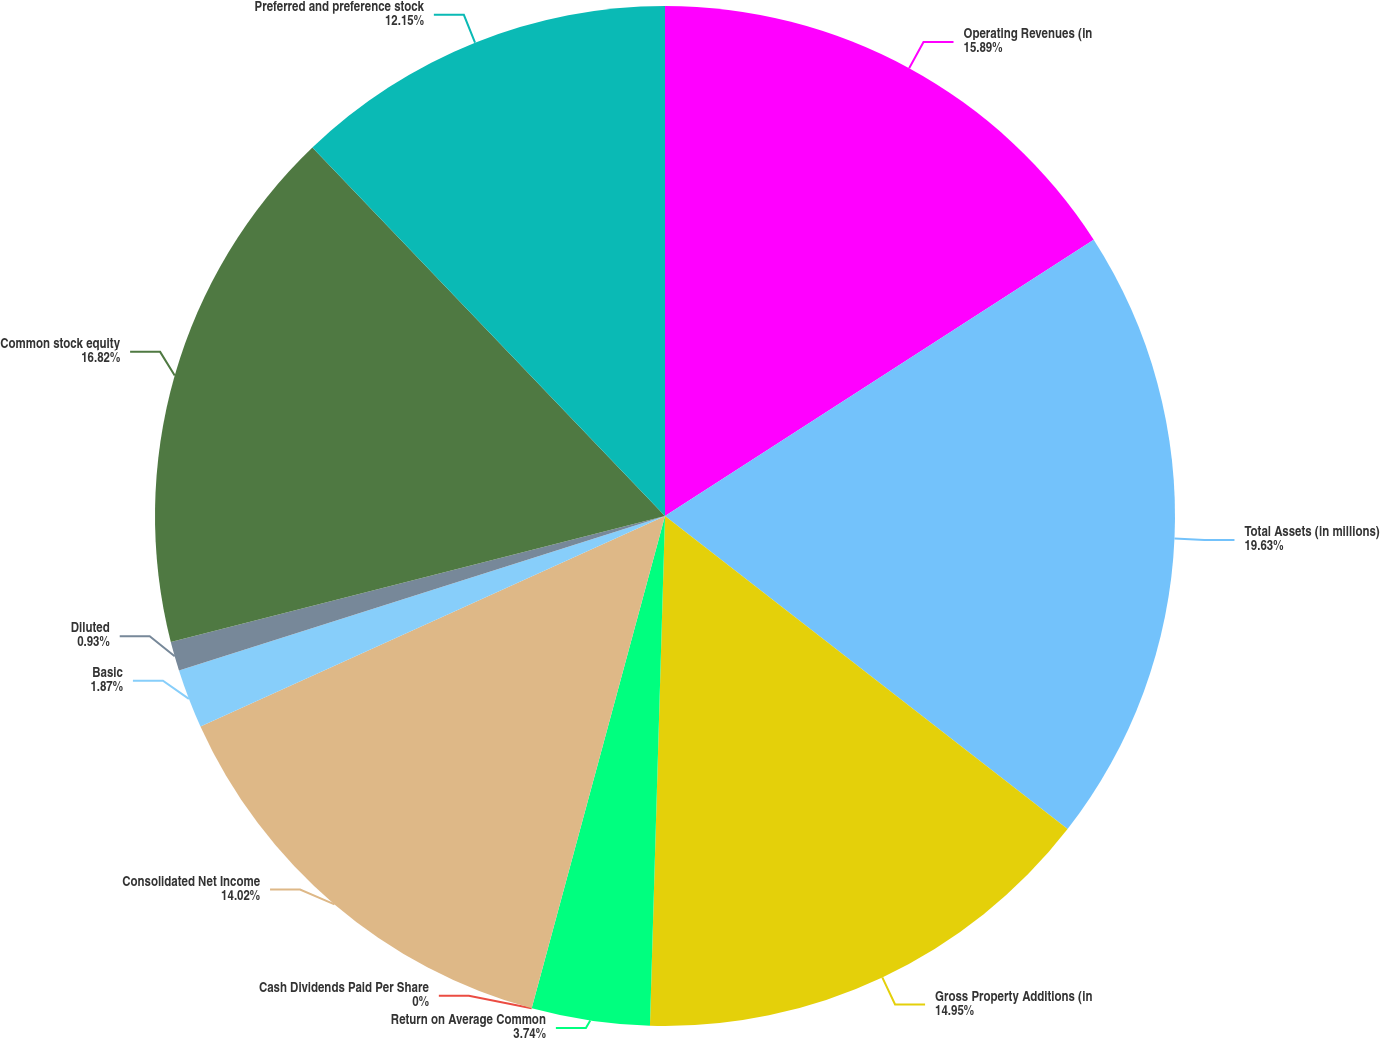<chart> <loc_0><loc_0><loc_500><loc_500><pie_chart><fcel>Operating Revenues (in<fcel>Total Assets (in millions)<fcel>Gross Property Additions (in<fcel>Return on Average Common<fcel>Cash Dividends Paid Per Share<fcel>Consolidated Net Income<fcel>Basic<fcel>Diluted<fcel>Common stock equity<fcel>Preferred and preference stock<nl><fcel>15.89%<fcel>19.63%<fcel>14.95%<fcel>3.74%<fcel>0.0%<fcel>14.02%<fcel>1.87%<fcel>0.93%<fcel>16.82%<fcel>12.15%<nl></chart> 